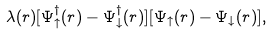Convert formula to latex. <formula><loc_0><loc_0><loc_500><loc_500>\lambda ( { r } ) [ \Psi _ { \uparrow } ^ { \dagger } ( { r } ) - \Psi _ { \downarrow } ^ { \dagger } ( { r } ) ] [ \Psi _ { \uparrow } ( { r } ) - \Psi _ { \downarrow } ( { r } ) ] ,</formula> 